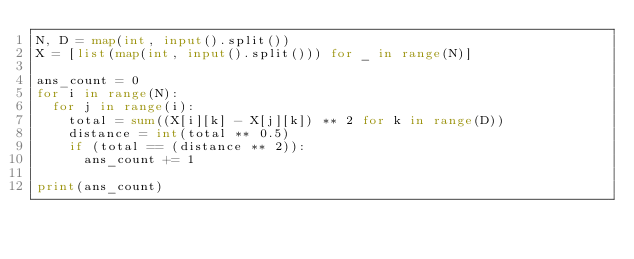Convert code to text. <code><loc_0><loc_0><loc_500><loc_500><_Python_>N, D = map(int, input().split())
X = [list(map(int, input().split())) for _ in range(N)]

ans_count = 0
for i in range(N):
  for j in range(i):
    total = sum((X[i][k] - X[j][k]) ** 2 for k in range(D))
    distance = int(total ** 0.5)
    if (total == (distance ** 2)):
      ans_count += 1

print(ans_count)</code> 